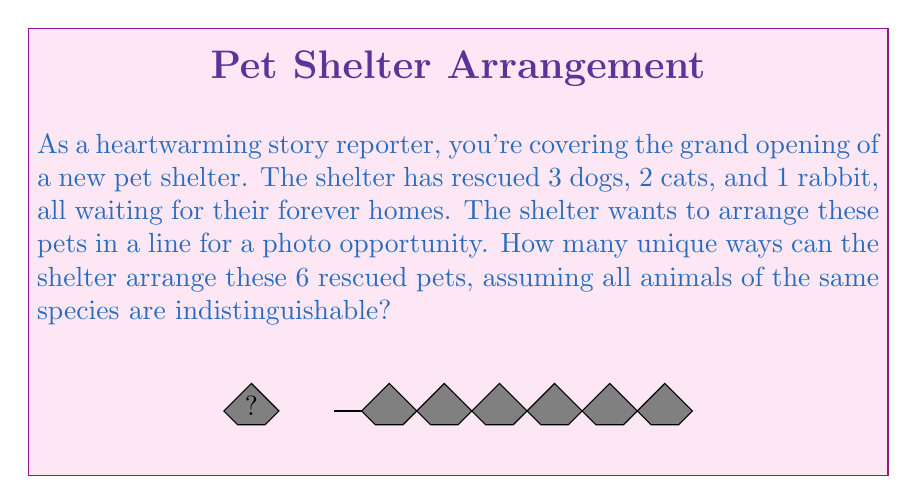Can you solve this math problem? Let's approach this step-by-step using principles from Group theory:

1) This is a permutation problem with repetition. We have:
   - 3 indistinguishable dogs
   - 2 indistinguishable cats
   - 1 rabbit

2) The total number of pets is 3 + 2 + 1 = 6.

3) If all pets were distinguishable, we would have 6! arrangements. However, since some are indistinguishable, we need to account for this.

4) We use the formula for permutations with repetition:

   $$ \text{Number of unique arrangements} = \frac{n!}{n_1! \cdot n_2! \cdot ... \cdot n_k!} $$

   Where:
   - $n$ is the total number of items
   - $n_1, n_2, ..., n_k$ are the numbers of each type of indistinguishable item

5) Plugging in our values:

   $$ \text{Number of unique arrangements} = \frac{6!}{3! \cdot 2! \cdot 1!} $$

6) Let's calculate this:
   
   $$ \frac{6!}{3! \cdot 2! \cdot 1!} = \frac{6 \cdot 5 \cdot 4 \cdot 3!}{3! \cdot 2 \cdot 1 \cdot 1} = \frac{120}{2} = 60 $$

Therefore, there are 60 unique ways to arrange the rescued pets.
Answer: 60 